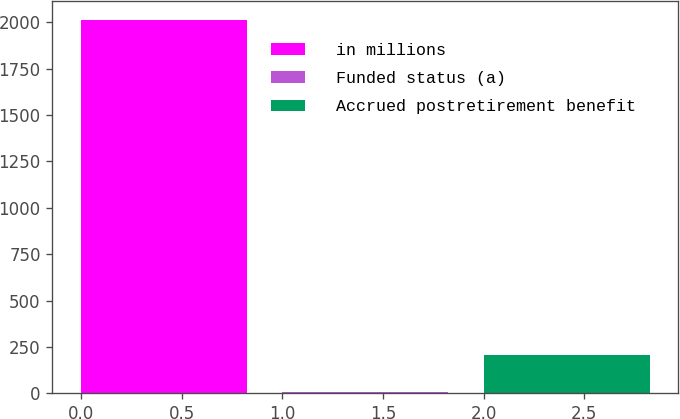Convert chart. <chart><loc_0><loc_0><loc_500><loc_500><bar_chart><fcel>in millions<fcel>Funded status (a)<fcel>Accrued postretirement benefit<nl><fcel>2013<fcel>8<fcel>208.5<nl></chart> 